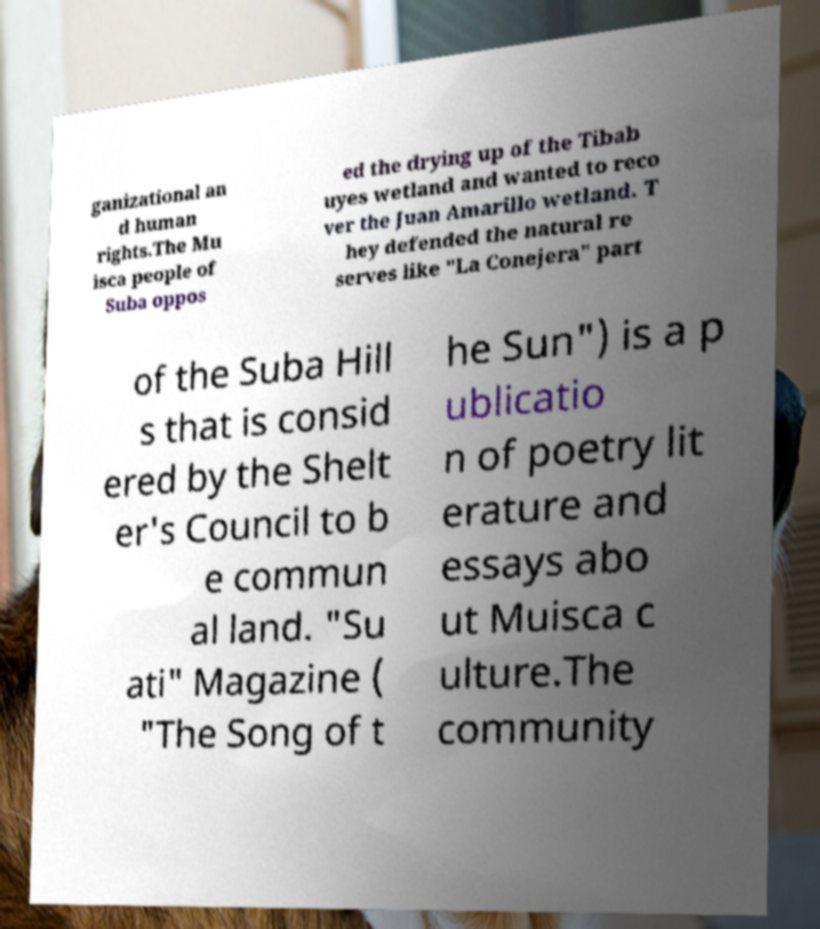There's text embedded in this image that I need extracted. Can you transcribe it verbatim? ganizational an d human rights.The Mu isca people of Suba oppos ed the drying up of the Tibab uyes wetland and wanted to reco ver the Juan Amarillo wetland. T hey defended the natural re serves like "La Conejera" part of the Suba Hill s that is consid ered by the Shelt er's Council to b e commun al land. "Su ati" Magazine ( "The Song of t he Sun") is a p ublicatio n of poetry lit erature and essays abo ut Muisca c ulture.The community 